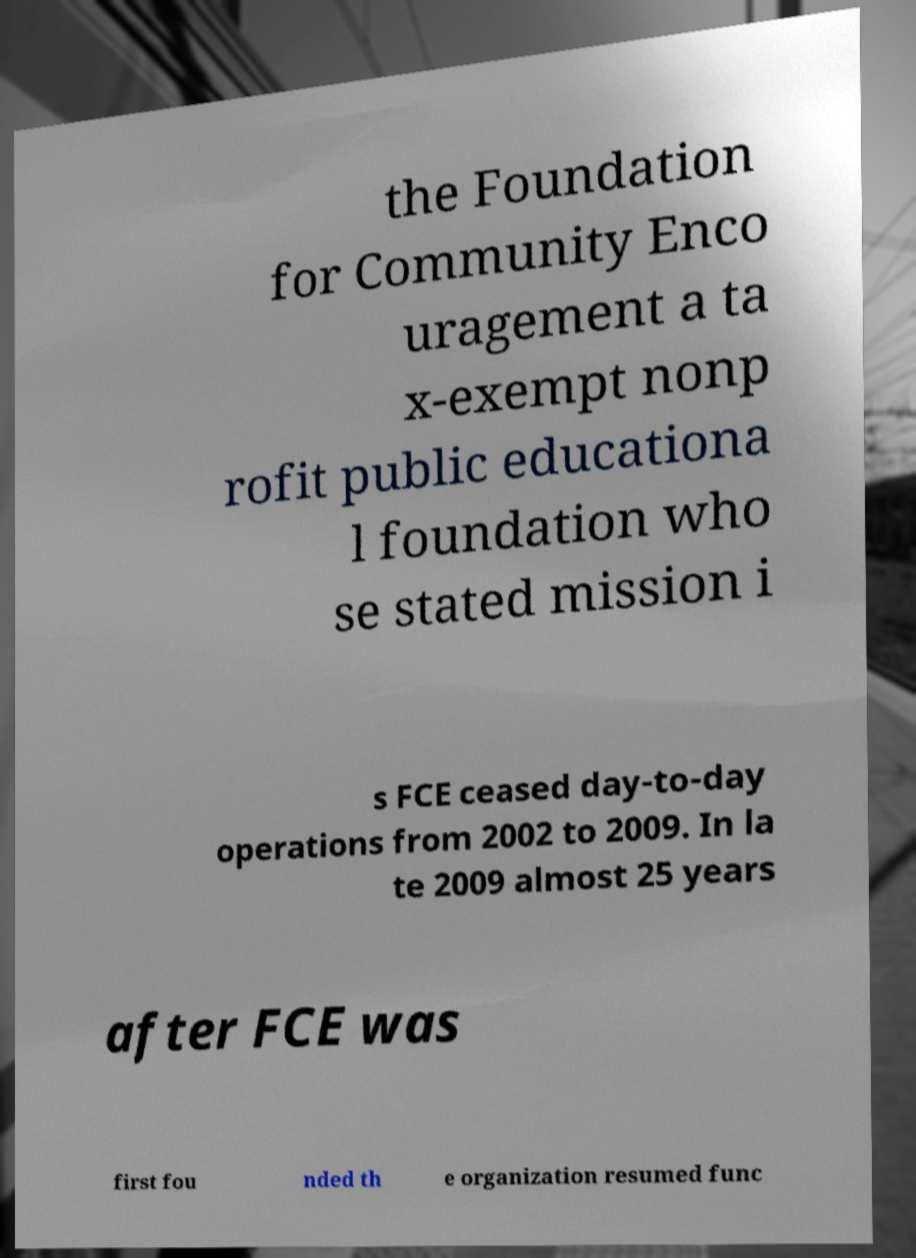What messages or text are displayed in this image? I need them in a readable, typed format. the Foundation for Community Enco uragement a ta x-exempt nonp rofit public educationa l foundation who se stated mission i s FCE ceased day-to-day operations from 2002 to 2009. In la te 2009 almost 25 years after FCE was first fou nded th e organization resumed func 